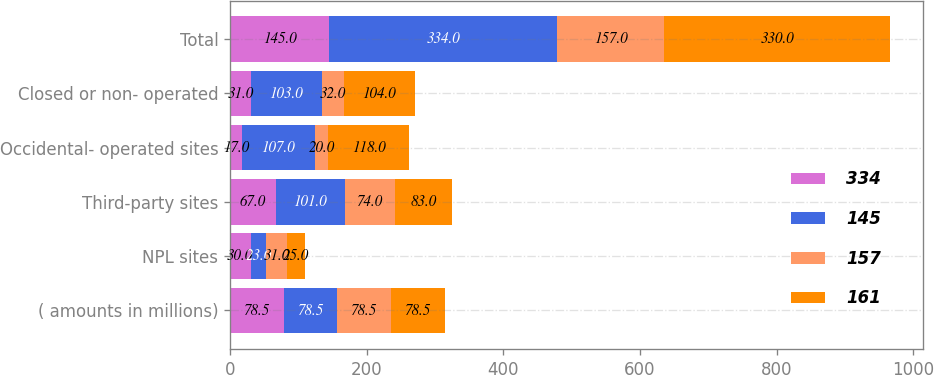<chart> <loc_0><loc_0><loc_500><loc_500><stacked_bar_chart><ecel><fcel>( amounts in millions)<fcel>NPL sites<fcel>Third-party sites<fcel>Occidental- operated sites<fcel>Closed or non- operated<fcel>Total<nl><fcel>334<fcel>78.5<fcel>30<fcel>67<fcel>17<fcel>31<fcel>145<nl><fcel>145<fcel>78.5<fcel>23<fcel>101<fcel>107<fcel>103<fcel>334<nl><fcel>157<fcel>78.5<fcel>31<fcel>74<fcel>20<fcel>32<fcel>157<nl><fcel>161<fcel>78.5<fcel>25<fcel>83<fcel>118<fcel>104<fcel>330<nl></chart> 